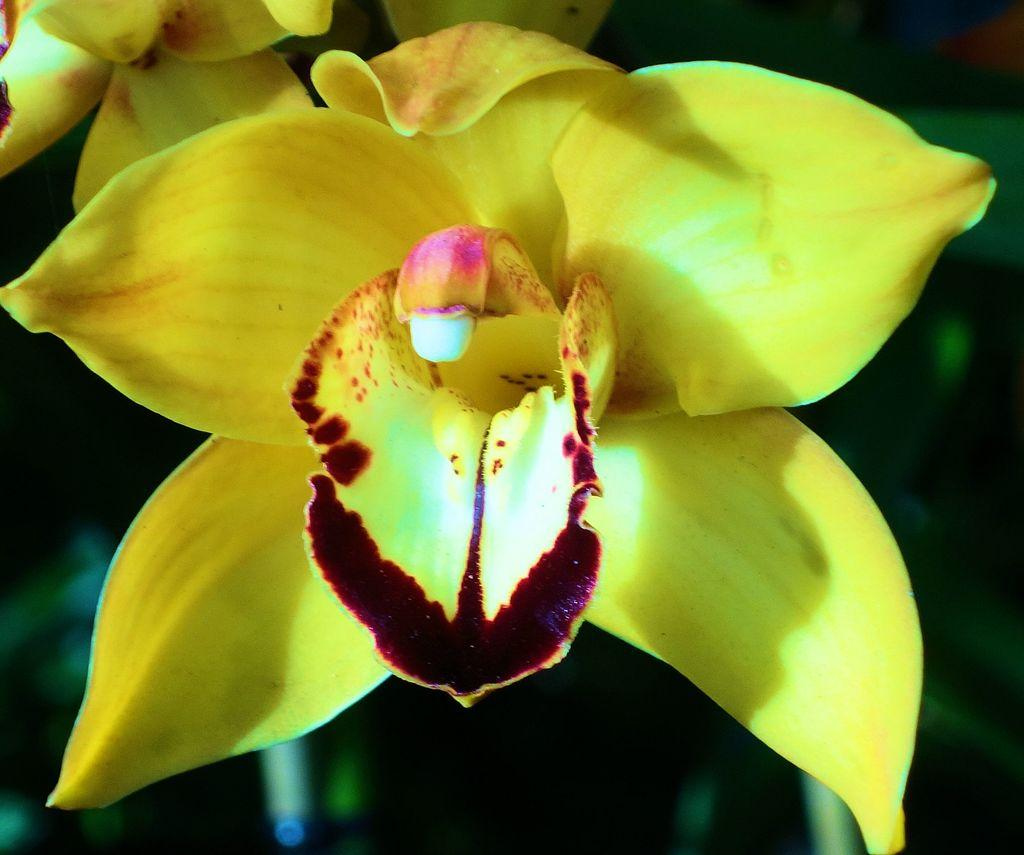What type of flower is in the foreground of the image? There is a yellow flower in the foreground of the image. How many flowers are in the background of the image? There are two flowers in the background of the image. Can you describe the background of the image? The background of the image is blurry. What type of credit card is visible in the image? There is no credit card present in the image; it features flowers. 